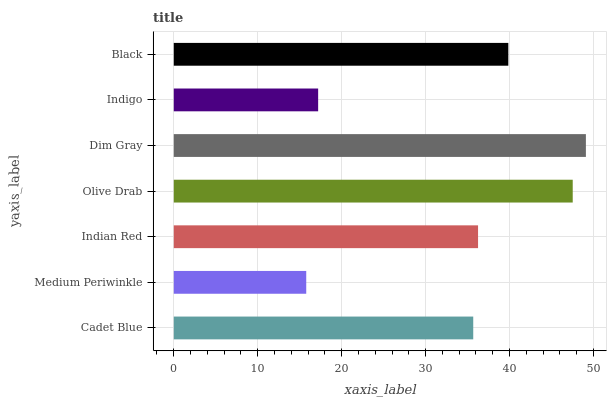Is Medium Periwinkle the minimum?
Answer yes or no. Yes. Is Dim Gray the maximum?
Answer yes or no. Yes. Is Indian Red the minimum?
Answer yes or no. No. Is Indian Red the maximum?
Answer yes or no. No. Is Indian Red greater than Medium Periwinkle?
Answer yes or no. Yes. Is Medium Periwinkle less than Indian Red?
Answer yes or no. Yes. Is Medium Periwinkle greater than Indian Red?
Answer yes or no. No. Is Indian Red less than Medium Periwinkle?
Answer yes or no. No. Is Indian Red the high median?
Answer yes or no. Yes. Is Indian Red the low median?
Answer yes or no. Yes. Is Medium Periwinkle the high median?
Answer yes or no. No. Is Medium Periwinkle the low median?
Answer yes or no. No. 